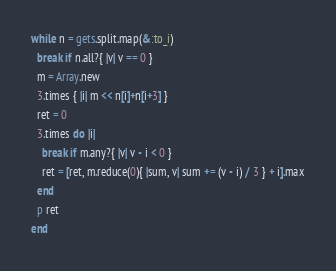<code> <loc_0><loc_0><loc_500><loc_500><_Ruby_>while n = gets.split.map(&:to_i)
  break if n.all?{ |v| v == 0 }
  m = Array.new
  3.times { |i| m << n[i]+n[i+3] }
  ret = 0
  3.times do |i|
    break if m.any?{ |v| v - i < 0 }
    ret = [ret, m.reduce(0){ |sum, v| sum += (v - i) / 3 } + i].max
  end
  p ret
end</code> 